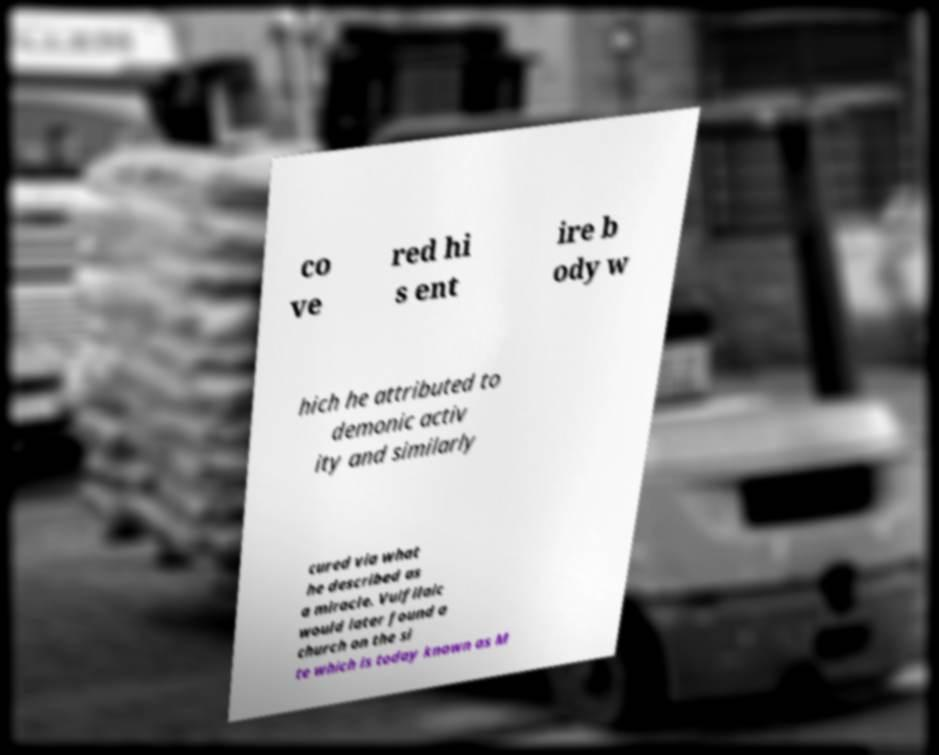I need the written content from this picture converted into text. Can you do that? co ve red hi s ent ire b ody w hich he attributed to demonic activ ity and similarly cured via what he described as a miracle. Vulfilaic would later found a church on the si te which is today known as M 